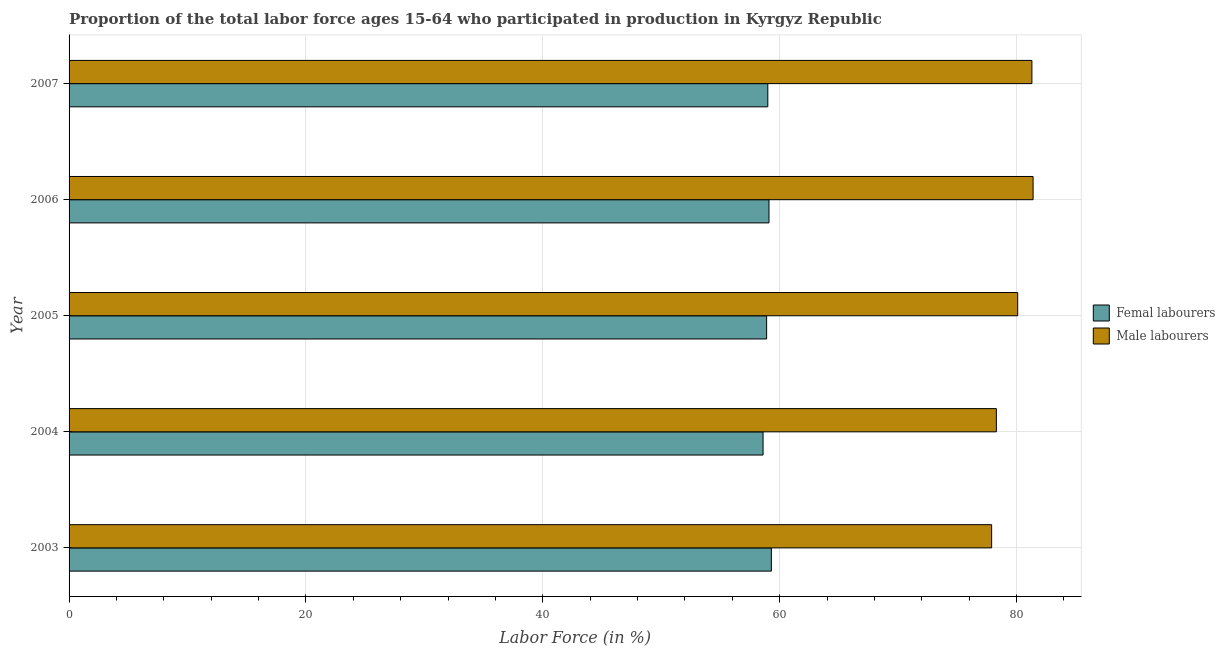Are the number of bars per tick equal to the number of legend labels?
Your answer should be compact. Yes. Are the number of bars on each tick of the Y-axis equal?
Provide a succinct answer. Yes. How many bars are there on the 2nd tick from the top?
Keep it short and to the point. 2. How many bars are there on the 1st tick from the bottom?
Your response must be concise. 2. What is the label of the 5th group of bars from the top?
Ensure brevity in your answer.  2003. What is the percentage of female labor force in 2003?
Your answer should be compact. 59.3. Across all years, what is the maximum percentage of male labour force?
Give a very brief answer. 81.4. Across all years, what is the minimum percentage of male labour force?
Your answer should be very brief. 77.9. In which year was the percentage of female labor force maximum?
Provide a short and direct response. 2003. What is the total percentage of male labour force in the graph?
Ensure brevity in your answer.  399. What is the difference between the percentage of male labour force in 2005 and the percentage of female labor force in 2003?
Offer a very short reply. 20.8. What is the average percentage of female labor force per year?
Your answer should be compact. 58.98. In the year 2005, what is the difference between the percentage of male labour force and percentage of female labor force?
Your answer should be compact. 21.2. Is the percentage of male labour force in 2003 less than that in 2004?
Provide a succinct answer. Yes. Is the difference between the percentage of female labor force in 2005 and 2006 greater than the difference between the percentage of male labour force in 2005 and 2006?
Provide a short and direct response. Yes. What is the difference between the highest and the second highest percentage of female labor force?
Provide a succinct answer. 0.2. What does the 1st bar from the top in 2003 represents?
Provide a succinct answer. Male labourers. What does the 1st bar from the bottom in 2007 represents?
Keep it short and to the point. Femal labourers. How many years are there in the graph?
Your answer should be very brief. 5. Where does the legend appear in the graph?
Provide a succinct answer. Center right. What is the title of the graph?
Give a very brief answer. Proportion of the total labor force ages 15-64 who participated in production in Kyrgyz Republic. Does "Commercial bank branches" appear as one of the legend labels in the graph?
Give a very brief answer. No. What is the label or title of the X-axis?
Give a very brief answer. Labor Force (in %). What is the Labor Force (in %) in Femal labourers in 2003?
Keep it short and to the point. 59.3. What is the Labor Force (in %) of Male labourers in 2003?
Your response must be concise. 77.9. What is the Labor Force (in %) of Femal labourers in 2004?
Offer a terse response. 58.6. What is the Labor Force (in %) in Male labourers in 2004?
Offer a very short reply. 78.3. What is the Labor Force (in %) of Femal labourers in 2005?
Offer a terse response. 58.9. What is the Labor Force (in %) in Male labourers in 2005?
Keep it short and to the point. 80.1. What is the Labor Force (in %) of Femal labourers in 2006?
Provide a short and direct response. 59.1. What is the Labor Force (in %) of Male labourers in 2006?
Give a very brief answer. 81.4. What is the Labor Force (in %) in Femal labourers in 2007?
Provide a short and direct response. 59. What is the Labor Force (in %) in Male labourers in 2007?
Ensure brevity in your answer.  81.3. Across all years, what is the maximum Labor Force (in %) of Femal labourers?
Offer a terse response. 59.3. Across all years, what is the maximum Labor Force (in %) of Male labourers?
Your answer should be compact. 81.4. Across all years, what is the minimum Labor Force (in %) in Femal labourers?
Keep it short and to the point. 58.6. Across all years, what is the minimum Labor Force (in %) in Male labourers?
Provide a short and direct response. 77.9. What is the total Labor Force (in %) in Femal labourers in the graph?
Make the answer very short. 294.9. What is the total Labor Force (in %) of Male labourers in the graph?
Provide a short and direct response. 399. What is the difference between the Labor Force (in %) in Femal labourers in 2003 and that in 2005?
Keep it short and to the point. 0.4. What is the difference between the Labor Force (in %) in Male labourers in 2003 and that in 2005?
Keep it short and to the point. -2.2. What is the difference between the Labor Force (in %) of Male labourers in 2003 and that in 2006?
Provide a short and direct response. -3.5. What is the difference between the Labor Force (in %) in Femal labourers in 2003 and that in 2007?
Offer a very short reply. 0.3. What is the difference between the Labor Force (in %) of Male labourers in 2003 and that in 2007?
Give a very brief answer. -3.4. What is the difference between the Labor Force (in %) in Male labourers in 2004 and that in 2005?
Keep it short and to the point. -1.8. What is the difference between the Labor Force (in %) in Femal labourers in 2004 and that in 2006?
Your answer should be very brief. -0.5. What is the difference between the Labor Force (in %) in Male labourers in 2004 and that in 2006?
Make the answer very short. -3.1. What is the difference between the Labor Force (in %) in Femal labourers in 2004 and that in 2007?
Your answer should be very brief. -0.4. What is the difference between the Labor Force (in %) of Femal labourers in 2005 and that in 2006?
Provide a succinct answer. -0.2. What is the difference between the Labor Force (in %) of Femal labourers in 2003 and the Labor Force (in %) of Male labourers in 2005?
Give a very brief answer. -20.8. What is the difference between the Labor Force (in %) in Femal labourers in 2003 and the Labor Force (in %) in Male labourers in 2006?
Your answer should be compact. -22.1. What is the difference between the Labor Force (in %) of Femal labourers in 2004 and the Labor Force (in %) of Male labourers in 2005?
Your response must be concise. -21.5. What is the difference between the Labor Force (in %) in Femal labourers in 2004 and the Labor Force (in %) in Male labourers in 2006?
Your answer should be compact. -22.8. What is the difference between the Labor Force (in %) in Femal labourers in 2004 and the Labor Force (in %) in Male labourers in 2007?
Keep it short and to the point. -22.7. What is the difference between the Labor Force (in %) of Femal labourers in 2005 and the Labor Force (in %) of Male labourers in 2006?
Give a very brief answer. -22.5. What is the difference between the Labor Force (in %) in Femal labourers in 2005 and the Labor Force (in %) in Male labourers in 2007?
Provide a succinct answer. -22.4. What is the difference between the Labor Force (in %) of Femal labourers in 2006 and the Labor Force (in %) of Male labourers in 2007?
Keep it short and to the point. -22.2. What is the average Labor Force (in %) in Femal labourers per year?
Your answer should be compact. 58.98. What is the average Labor Force (in %) in Male labourers per year?
Your answer should be very brief. 79.8. In the year 2003, what is the difference between the Labor Force (in %) in Femal labourers and Labor Force (in %) in Male labourers?
Provide a succinct answer. -18.6. In the year 2004, what is the difference between the Labor Force (in %) of Femal labourers and Labor Force (in %) of Male labourers?
Ensure brevity in your answer.  -19.7. In the year 2005, what is the difference between the Labor Force (in %) in Femal labourers and Labor Force (in %) in Male labourers?
Provide a succinct answer. -21.2. In the year 2006, what is the difference between the Labor Force (in %) in Femal labourers and Labor Force (in %) in Male labourers?
Your answer should be very brief. -22.3. In the year 2007, what is the difference between the Labor Force (in %) of Femal labourers and Labor Force (in %) of Male labourers?
Offer a terse response. -22.3. What is the ratio of the Labor Force (in %) in Femal labourers in 2003 to that in 2004?
Ensure brevity in your answer.  1.01. What is the ratio of the Labor Force (in %) in Femal labourers in 2003 to that in 2005?
Give a very brief answer. 1.01. What is the ratio of the Labor Force (in %) in Male labourers in 2003 to that in 2005?
Make the answer very short. 0.97. What is the ratio of the Labor Force (in %) of Femal labourers in 2003 to that in 2007?
Give a very brief answer. 1.01. What is the ratio of the Labor Force (in %) of Male labourers in 2003 to that in 2007?
Offer a very short reply. 0.96. What is the ratio of the Labor Force (in %) in Femal labourers in 2004 to that in 2005?
Provide a succinct answer. 0.99. What is the ratio of the Labor Force (in %) of Male labourers in 2004 to that in 2005?
Your answer should be very brief. 0.98. What is the ratio of the Labor Force (in %) in Femal labourers in 2004 to that in 2006?
Your answer should be compact. 0.99. What is the ratio of the Labor Force (in %) of Male labourers in 2004 to that in 2006?
Offer a very short reply. 0.96. What is the ratio of the Labor Force (in %) in Male labourers in 2004 to that in 2007?
Keep it short and to the point. 0.96. What is the ratio of the Labor Force (in %) of Femal labourers in 2005 to that in 2007?
Offer a very short reply. 1. What is the ratio of the Labor Force (in %) of Male labourers in 2005 to that in 2007?
Your response must be concise. 0.99. What is the ratio of the Labor Force (in %) in Male labourers in 2006 to that in 2007?
Your answer should be very brief. 1. What is the difference between the highest and the second highest Labor Force (in %) in Femal labourers?
Offer a terse response. 0.2. 